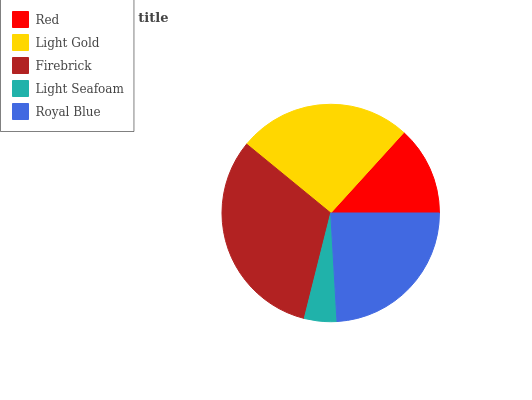Is Light Seafoam the minimum?
Answer yes or no. Yes. Is Firebrick the maximum?
Answer yes or no. Yes. Is Light Gold the minimum?
Answer yes or no. No. Is Light Gold the maximum?
Answer yes or no. No. Is Light Gold greater than Red?
Answer yes or no. Yes. Is Red less than Light Gold?
Answer yes or no. Yes. Is Red greater than Light Gold?
Answer yes or no. No. Is Light Gold less than Red?
Answer yes or no. No. Is Royal Blue the high median?
Answer yes or no. Yes. Is Royal Blue the low median?
Answer yes or no. Yes. Is Firebrick the high median?
Answer yes or no. No. Is Light Seafoam the low median?
Answer yes or no. No. 